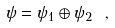<formula> <loc_0><loc_0><loc_500><loc_500>\psi = \psi _ { 1 } \oplus \psi _ { 2 } \ ,</formula> 